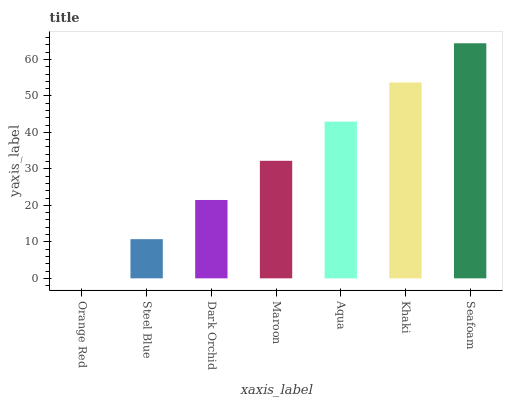Is Orange Red the minimum?
Answer yes or no. Yes. Is Seafoam the maximum?
Answer yes or no. Yes. Is Steel Blue the minimum?
Answer yes or no. No. Is Steel Blue the maximum?
Answer yes or no. No. Is Steel Blue greater than Orange Red?
Answer yes or no. Yes. Is Orange Red less than Steel Blue?
Answer yes or no. Yes. Is Orange Red greater than Steel Blue?
Answer yes or no. No. Is Steel Blue less than Orange Red?
Answer yes or no. No. Is Maroon the high median?
Answer yes or no. Yes. Is Maroon the low median?
Answer yes or no. Yes. Is Seafoam the high median?
Answer yes or no. No. Is Aqua the low median?
Answer yes or no. No. 